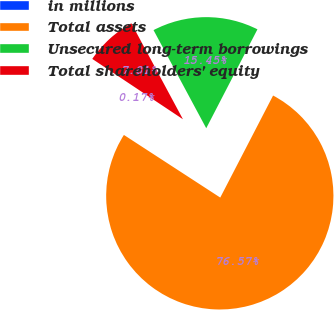Convert chart. <chart><loc_0><loc_0><loc_500><loc_500><pie_chart><fcel>in millions<fcel>Total assets<fcel>Unsecured long-term borrowings<fcel>Total shareholders' equity<nl><fcel>0.17%<fcel>76.57%<fcel>15.45%<fcel>7.81%<nl></chart> 